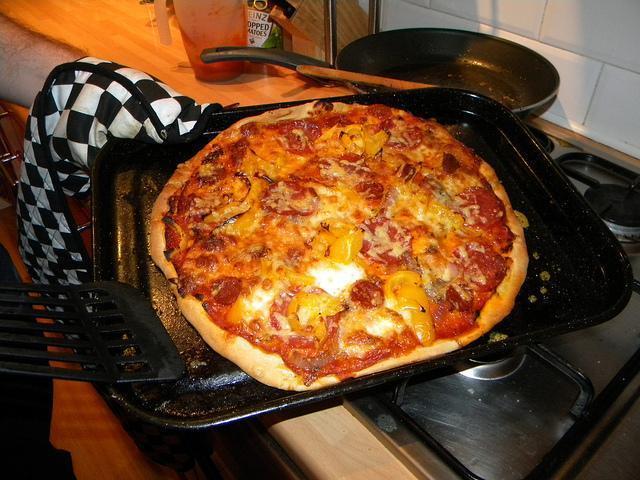Is the caption "The oven is below the pizza." a true representation of the image?
Answer yes or no. Yes. Is the statement "The pizza is out of the oven." accurate regarding the image?
Answer yes or no. Yes. 